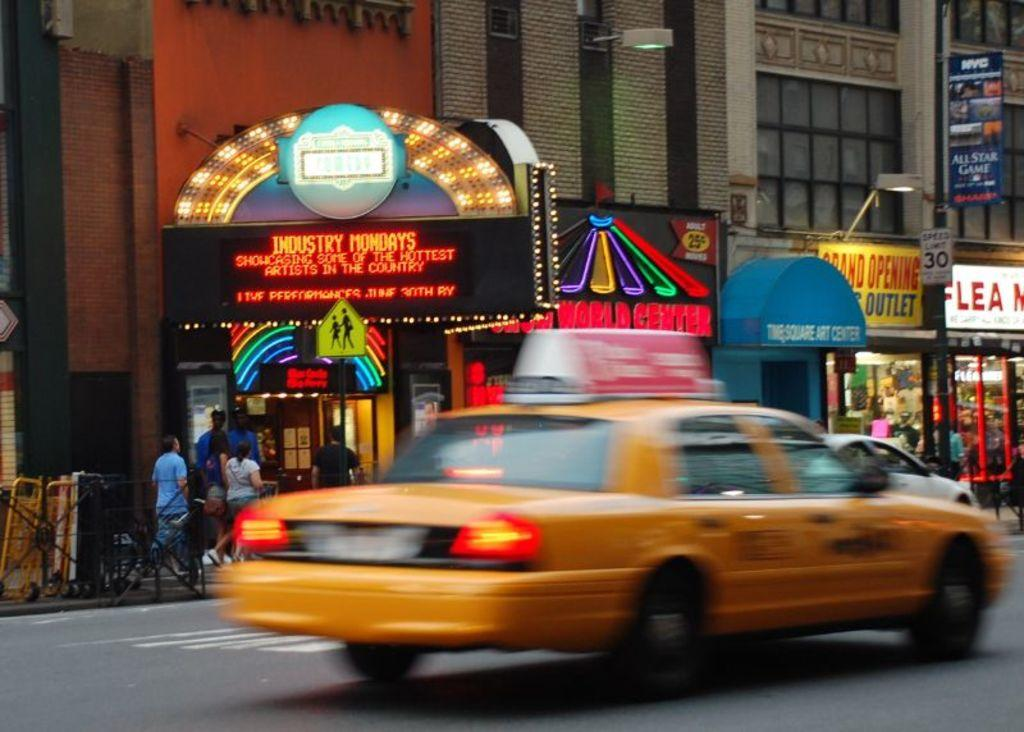<image>
Write a terse but informative summary of the picture. A yellow taxi passes by an electronic sign advertising Industry Mondays. 